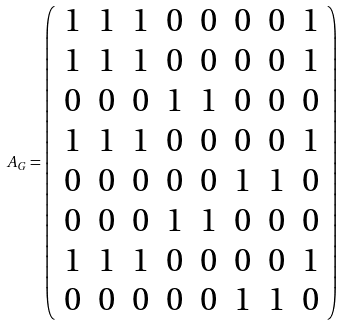<formula> <loc_0><loc_0><loc_500><loc_500>A _ { G } = \left ( \begin{array} { c c c c c c c c } 1 & 1 & 1 & 0 & 0 & 0 & 0 & 1 \\ 1 & 1 & 1 & 0 & 0 & 0 & 0 & 1 \\ 0 & 0 & 0 & 1 & 1 & 0 & 0 & 0 \\ 1 & 1 & 1 & 0 & 0 & 0 & 0 & 1 \\ 0 & 0 & 0 & 0 & 0 & 1 & 1 & 0 \\ 0 & 0 & 0 & 1 & 1 & 0 & 0 & 0 \\ 1 & 1 & 1 & 0 & 0 & 0 & 0 & 1 \\ 0 & 0 & 0 & 0 & 0 & 1 & 1 & 0 \\ \end{array} \right )</formula> 